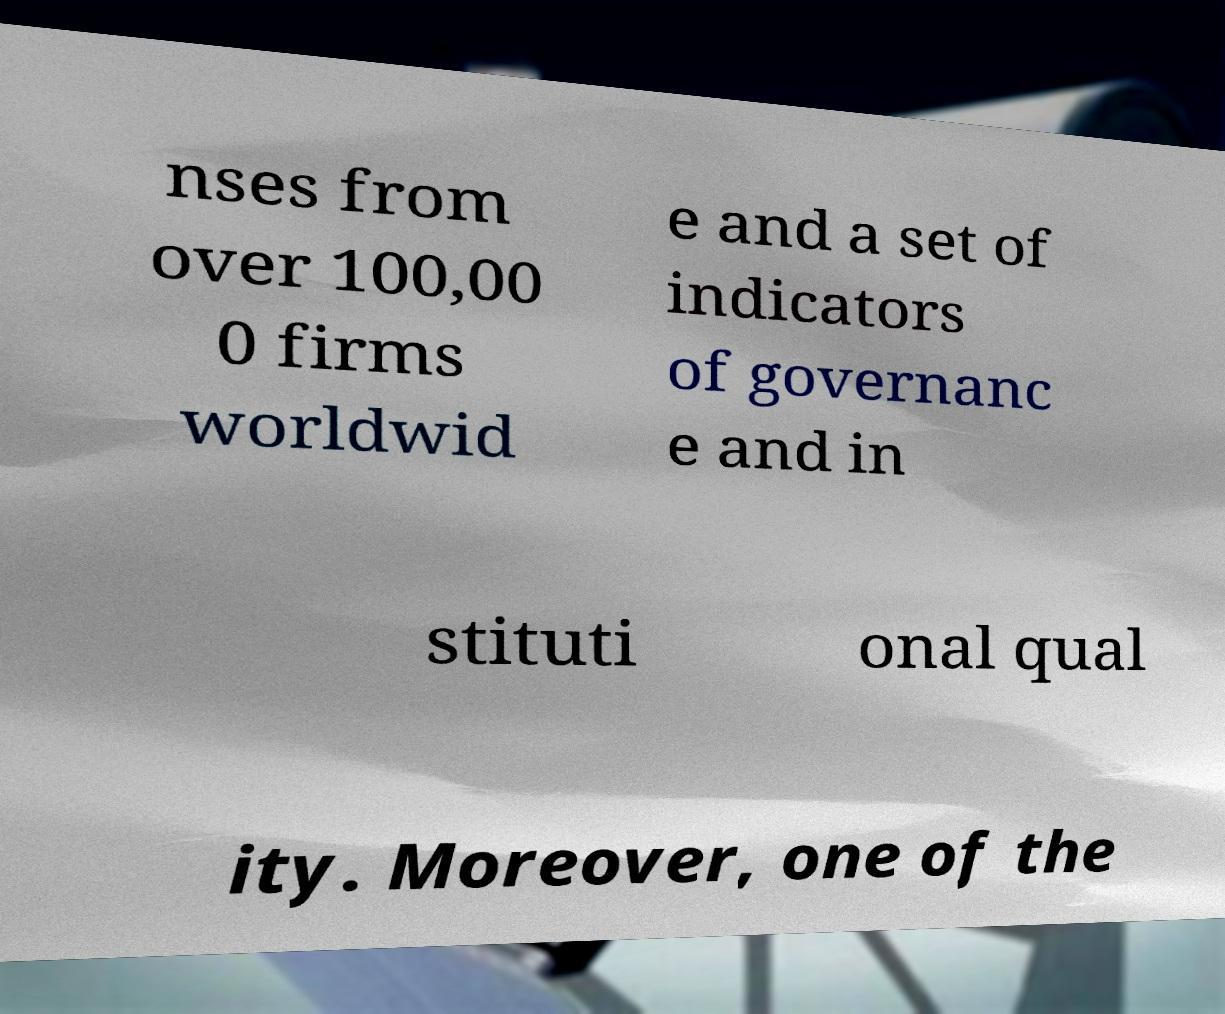What messages or text are displayed in this image? I need them in a readable, typed format. nses from over 100,00 0 firms worldwid e and a set of indicators of governanc e and in stituti onal qual ity. Moreover, one of the 